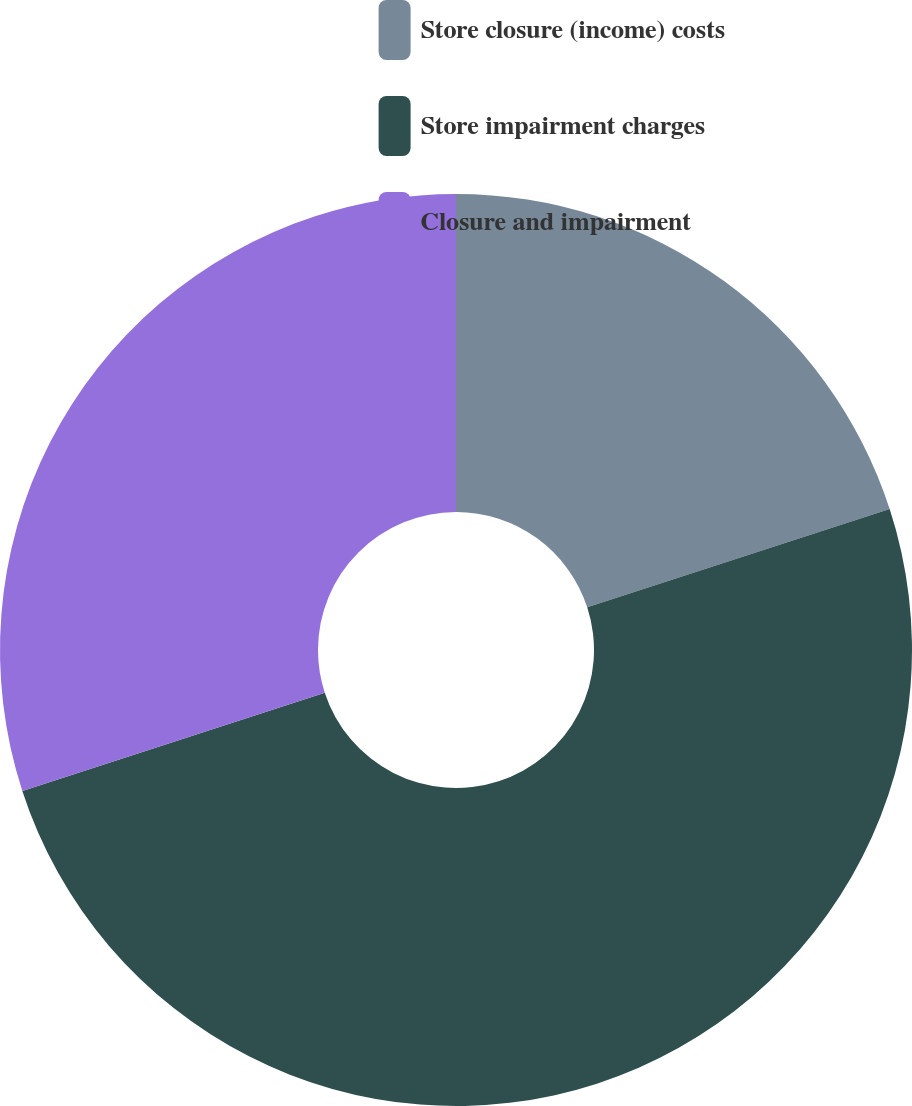Convert chart. <chart><loc_0><loc_0><loc_500><loc_500><pie_chart><fcel>Store closure (income) costs<fcel>Store impairment charges<fcel>Closure and impairment<nl><fcel>20.0%<fcel>50.0%<fcel>30.0%<nl></chart> 